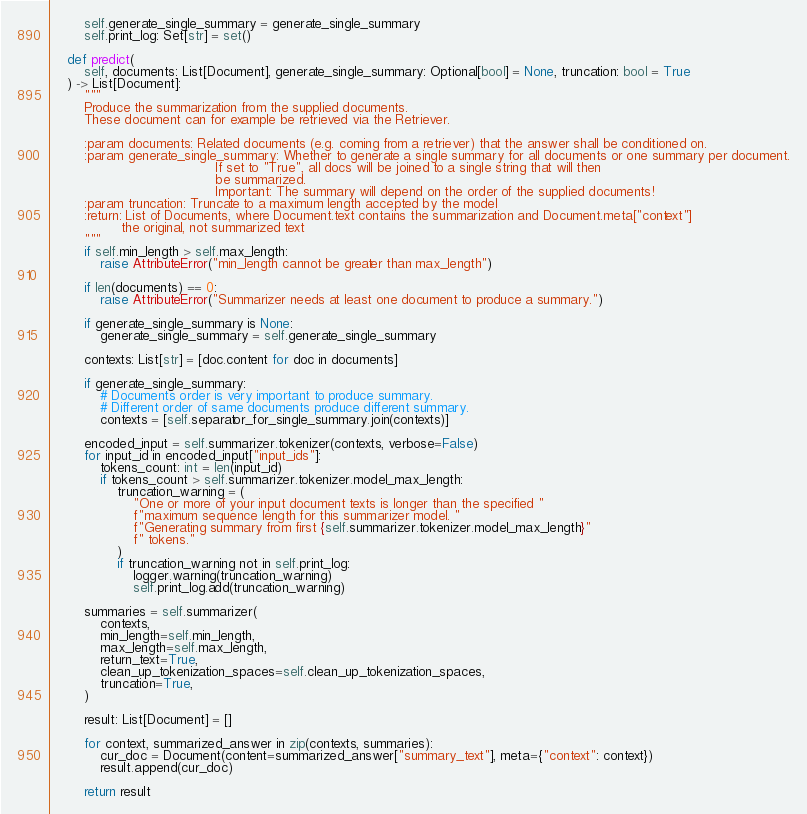<code> <loc_0><loc_0><loc_500><loc_500><_Python_>        self.generate_single_summary = generate_single_summary
        self.print_log: Set[str] = set()

    def predict(
        self, documents: List[Document], generate_single_summary: Optional[bool] = None, truncation: bool = True
    ) -> List[Document]:
        """
        Produce the summarization from the supplied documents.
        These document can for example be retrieved via the Retriever.

        :param documents: Related documents (e.g. coming from a retriever) that the answer shall be conditioned on.
        :param generate_single_summary: Whether to generate a single summary for all documents or one summary per document.
                                        If set to "True", all docs will be joined to a single string that will then
                                        be summarized.
                                        Important: The summary will depend on the order of the supplied documents!
        :param truncation: Truncate to a maximum length accepted by the model
        :return: List of Documents, where Document.text contains the summarization and Document.meta["context"]
                 the original, not summarized text
        """
        if self.min_length > self.max_length:
            raise AttributeError("min_length cannot be greater than max_length")

        if len(documents) == 0:
            raise AttributeError("Summarizer needs at least one document to produce a summary.")

        if generate_single_summary is None:
            generate_single_summary = self.generate_single_summary

        contexts: List[str] = [doc.content for doc in documents]

        if generate_single_summary:
            # Documents order is very important to produce summary.
            # Different order of same documents produce different summary.
            contexts = [self.separator_for_single_summary.join(contexts)]

        encoded_input = self.summarizer.tokenizer(contexts, verbose=False)
        for input_id in encoded_input["input_ids"]:
            tokens_count: int = len(input_id)
            if tokens_count > self.summarizer.tokenizer.model_max_length:
                truncation_warning = (
                    "One or more of your input document texts is longer than the specified "
                    f"maximum sequence length for this summarizer model. "
                    f"Generating summary from first {self.summarizer.tokenizer.model_max_length}"
                    f" tokens."
                )
                if truncation_warning not in self.print_log:
                    logger.warning(truncation_warning)
                    self.print_log.add(truncation_warning)

        summaries = self.summarizer(
            contexts,
            min_length=self.min_length,
            max_length=self.max_length,
            return_text=True,
            clean_up_tokenization_spaces=self.clean_up_tokenization_spaces,
            truncation=True,
        )

        result: List[Document] = []

        for context, summarized_answer in zip(contexts, summaries):
            cur_doc = Document(content=summarized_answer["summary_text"], meta={"context": context})
            result.append(cur_doc)

        return result
</code> 